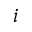<formula> <loc_0><loc_0><loc_500><loc_500>i</formula> 